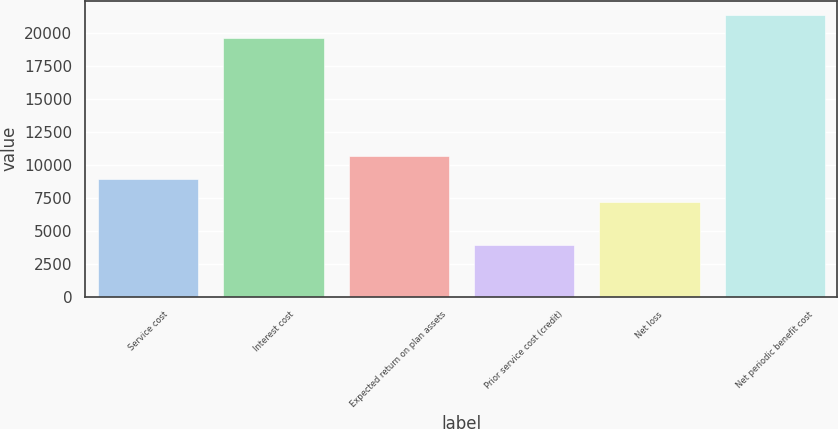Convert chart to OTSL. <chart><loc_0><loc_0><loc_500><loc_500><bar_chart><fcel>Service cost<fcel>Interest cost<fcel>Expected return on plan assets<fcel>Prior service cost (credit)<fcel>Net loss<fcel>Net periodic benefit cost<nl><fcel>8924.4<fcel>19644<fcel>10656.8<fcel>3878<fcel>7192<fcel>21376.4<nl></chart> 